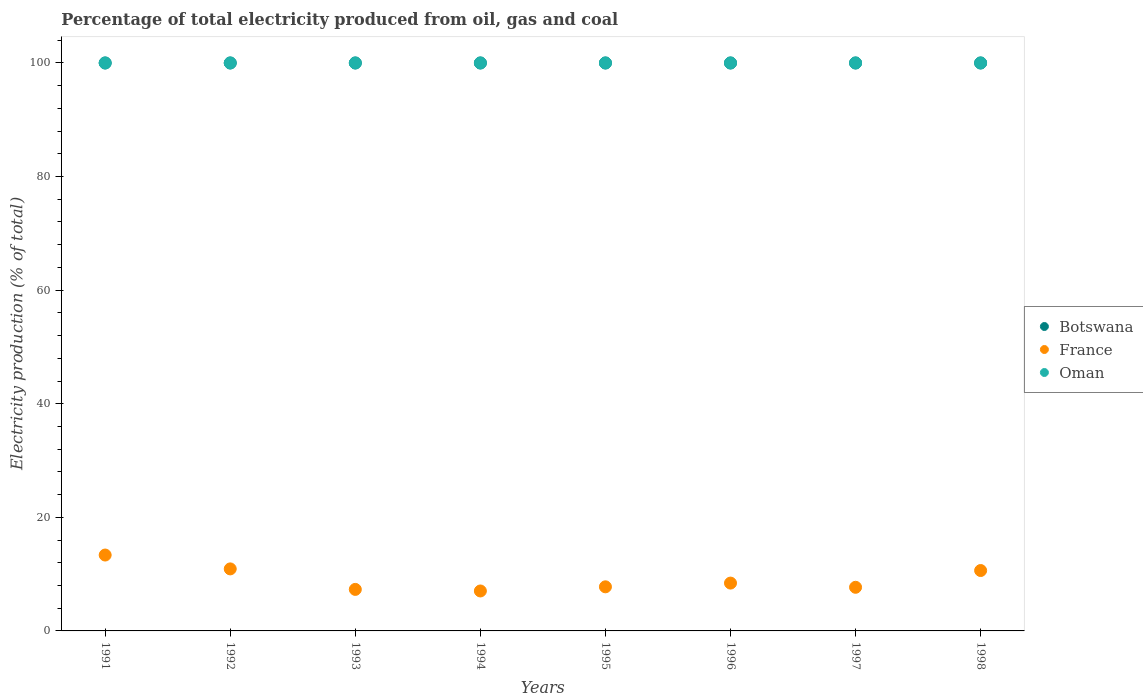How many different coloured dotlines are there?
Make the answer very short. 3. Is the number of dotlines equal to the number of legend labels?
Provide a short and direct response. Yes. In which year was the electricity production in in Botswana minimum?
Your answer should be very brief. 1991. What is the total electricity production in in Oman in the graph?
Your answer should be compact. 800. What is the difference between the electricity production in in France in 1995 and that in 1998?
Your response must be concise. -2.87. What is the average electricity production in in Botswana per year?
Provide a succinct answer. 100. In the year 1997, what is the difference between the electricity production in in France and electricity production in in Oman?
Offer a terse response. -92.32. What is the ratio of the electricity production in in Oman in 1994 to that in 1998?
Make the answer very short. 1. Is the difference between the electricity production in in France in 1991 and 1993 greater than the difference between the electricity production in in Oman in 1991 and 1993?
Provide a succinct answer. Yes. What is the difference between the highest and the second highest electricity production in in France?
Provide a short and direct response. 2.44. What is the difference between the highest and the lowest electricity production in in Botswana?
Your response must be concise. 0. In how many years, is the electricity production in in Botswana greater than the average electricity production in in Botswana taken over all years?
Offer a terse response. 0. Is the sum of the electricity production in in Botswana in 1991 and 1993 greater than the maximum electricity production in in France across all years?
Your answer should be compact. Yes. Is it the case that in every year, the sum of the electricity production in in France and electricity production in in Botswana  is greater than the electricity production in in Oman?
Offer a very short reply. Yes. Does the electricity production in in Botswana monotonically increase over the years?
Provide a succinct answer. No. How many dotlines are there?
Provide a succinct answer. 3. What is the difference between two consecutive major ticks on the Y-axis?
Your answer should be compact. 20. Does the graph contain grids?
Your answer should be compact. No. How many legend labels are there?
Your answer should be compact. 3. How are the legend labels stacked?
Give a very brief answer. Vertical. What is the title of the graph?
Make the answer very short. Percentage of total electricity produced from oil, gas and coal. Does "United Kingdom" appear as one of the legend labels in the graph?
Keep it short and to the point. No. What is the label or title of the X-axis?
Make the answer very short. Years. What is the label or title of the Y-axis?
Give a very brief answer. Electricity production (% of total). What is the Electricity production (% of total) of France in 1991?
Ensure brevity in your answer.  13.36. What is the Electricity production (% of total) in Oman in 1991?
Make the answer very short. 100. What is the Electricity production (% of total) of Botswana in 1992?
Your answer should be very brief. 100. What is the Electricity production (% of total) in France in 1992?
Offer a terse response. 10.92. What is the Electricity production (% of total) in Oman in 1992?
Offer a very short reply. 100. What is the Electricity production (% of total) of Botswana in 1993?
Ensure brevity in your answer.  100. What is the Electricity production (% of total) in France in 1993?
Offer a very short reply. 7.31. What is the Electricity production (% of total) in Oman in 1993?
Provide a short and direct response. 100. What is the Electricity production (% of total) in France in 1994?
Your response must be concise. 7.03. What is the Electricity production (% of total) of France in 1995?
Ensure brevity in your answer.  7.77. What is the Electricity production (% of total) in Oman in 1995?
Make the answer very short. 100. What is the Electricity production (% of total) in Botswana in 1996?
Give a very brief answer. 100. What is the Electricity production (% of total) in France in 1996?
Keep it short and to the point. 8.42. What is the Electricity production (% of total) of Botswana in 1997?
Your answer should be very brief. 100. What is the Electricity production (% of total) in France in 1997?
Ensure brevity in your answer.  7.68. What is the Electricity production (% of total) in Oman in 1997?
Offer a terse response. 100. What is the Electricity production (% of total) in France in 1998?
Make the answer very short. 10.63. Across all years, what is the maximum Electricity production (% of total) of Botswana?
Your response must be concise. 100. Across all years, what is the maximum Electricity production (% of total) of France?
Keep it short and to the point. 13.36. Across all years, what is the maximum Electricity production (% of total) in Oman?
Give a very brief answer. 100. Across all years, what is the minimum Electricity production (% of total) in France?
Make the answer very short. 7.03. Across all years, what is the minimum Electricity production (% of total) of Oman?
Offer a terse response. 100. What is the total Electricity production (% of total) of Botswana in the graph?
Provide a short and direct response. 800. What is the total Electricity production (% of total) in France in the graph?
Offer a terse response. 73.13. What is the total Electricity production (% of total) of Oman in the graph?
Offer a very short reply. 800. What is the difference between the Electricity production (% of total) of Botswana in 1991 and that in 1992?
Offer a terse response. 0. What is the difference between the Electricity production (% of total) of France in 1991 and that in 1992?
Make the answer very short. 2.44. What is the difference between the Electricity production (% of total) of Botswana in 1991 and that in 1993?
Make the answer very short. 0. What is the difference between the Electricity production (% of total) in France in 1991 and that in 1993?
Give a very brief answer. 6.05. What is the difference between the Electricity production (% of total) of Botswana in 1991 and that in 1994?
Your answer should be compact. 0. What is the difference between the Electricity production (% of total) in France in 1991 and that in 1994?
Give a very brief answer. 6.33. What is the difference between the Electricity production (% of total) in France in 1991 and that in 1995?
Provide a short and direct response. 5.6. What is the difference between the Electricity production (% of total) in Oman in 1991 and that in 1995?
Keep it short and to the point. 0. What is the difference between the Electricity production (% of total) of Botswana in 1991 and that in 1996?
Your answer should be very brief. 0. What is the difference between the Electricity production (% of total) in France in 1991 and that in 1996?
Provide a short and direct response. 4.94. What is the difference between the Electricity production (% of total) of Oman in 1991 and that in 1996?
Give a very brief answer. 0. What is the difference between the Electricity production (% of total) in France in 1991 and that in 1997?
Your response must be concise. 5.68. What is the difference between the Electricity production (% of total) of Botswana in 1991 and that in 1998?
Provide a short and direct response. 0. What is the difference between the Electricity production (% of total) of France in 1991 and that in 1998?
Offer a terse response. 2.73. What is the difference between the Electricity production (% of total) in Oman in 1991 and that in 1998?
Your answer should be very brief. 0. What is the difference between the Electricity production (% of total) of Botswana in 1992 and that in 1993?
Offer a terse response. 0. What is the difference between the Electricity production (% of total) in France in 1992 and that in 1993?
Your answer should be compact. 3.61. What is the difference between the Electricity production (% of total) in Oman in 1992 and that in 1993?
Ensure brevity in your answer.  0. What is the difference between the Electricity production (% of total) in Botswana in 1992 and that in 1994?
Make the answer very short. 0. What is the difference between the Electricity production (% of total) in France in 1992 and that in 1994?
Make the answer very short. 3.89. What is the difference between the Electricity production (% of total) of Botswana in 1992 and that in 1995?
Offer a terse response. 0. What is the difference between the Electricity production (% of total) of France in 1992 and that in 1995?
Make the answer very short. 3.15. What is the difference between the Electricity production (% of total) of Botswana in 1992 and that in 1996?
Your response must be concise. 0. What is the difference between the Electricity production (% of total) in France in 1992 and that in 1996?
Provide a succinct answer. 2.5. What is the difference between the Electricity production (% of total) in Botswana in 1992 and that in 1997?
Your answer should be very brief. 0. What is the difference between the Electricity production (% of total) in France in 1992 and that in 1997?
Provide a short and direct response. 3.24. What is the difference between the Electricity production (% of total) of Oman in 1992 and that in 1997?
Give a very brief answer. 0. What is the difference between the Electricity production (% of total) of France in 1992 and that in 1998?
Your answer should be very brief. 0.29. What is the difference between the Electricity production (% of total) in Oman in 1992 and that in 1998?
Your response must be concise. 0. What is the difference between the Electricity production (% of total) of France in 1993 and that in 1994?
Provide a succinct answer. 0.28. What is the difference between the Electricity production (% of total) of Oman in 1993 and that in 1994?
Offer a terse response. 0. What is the difference between the Electricity production (% of total) of France in 1993 and that in 1995?
Offer a terse response. -0.45. What is the difference between the Electricity production (% of total) of Oman in 1993 and that in 1995?
Your answer should be compact. 0. What is the difference between the Electricity production (% of total) of France in 1993 and that in 1996?
Offer a terse response. -1.11. What is the difference between the Electricity production (% of total) of Oman in 1993 and that in 1996?
Offer a very short reply. 0. What is the difference between the Electricity production (% of total) of France in 1993 and that in 1997?
Provide a succinct answer. -0.37. What is the difference between the Electricity production (% of total) of Oman in 1993 and that in 1997?
Give a very brief answer. 0. What is the difference between the Electricity production (% of total) in France in 1993 and that in 1998?
Offer a very short reply. -3.32. What is the difference between the Electricity production (% of total) in France in 1994 and that in 1995?
Your answer should be very brief. -0.73. What is the difference between the Electricity production (% of total) in Botswana in 1994 and that in 1996?
Ensure brevity in your answer.  0. What is the difference between the Electricity production (% of total) in France in 1994 and that in 1996?
Your response must be concise. -1.39. What is the difference between the Electricity production (% of total) of France in 1994 and that in 1997?
Ensure brevity in your answer.  -0.65. What is the difference between the Electricity production (% of total) in France in 1994 and that in 1998?
Provide a succinct answer. -3.6. What is the difference between the Electricity production (% of total) of Oman in 1994 and that in 1998?
Provide a short and direct response. 0. What is the difference between the Electricity production (% of total) of Botswana in 1995 and that in 1996?
Ensure brevity in your answer.  0. What is the difference between the Electricity production (% of total) of France in 1995 and that in 1996?
Your response must be concise. -0.66. What is the difference between the Electricity production (% of total) of Oman in 1995 and that in 1996?
Your response must be concise. 0. What is the difference between the Electricity production (% of total) of Botswana in 1995 and that in 1997?
Your answer should be very brief. 0. What is the difference between the Electricity production (% of total) in France in 1995 and that in 1997?
Offer a terse response. 0.08. What is the difference between the Electricity production (% of total) of Oman in 1995 and that in 1997?
Your answer should be very brief. 0. What is the difference between the Electricity production (% of total) in France in 1995 and that in 1998?
Your answer should be very brief. -2.87. What is the difference between the Electricity production (% of total) in Botswana in 1996 and that in 1997?
Make the answer very short. 0. What is the difference between the Electricity production (% of total) of France in 1996 and that in 1997?
Your response must be concise. 0.74. What is the difference between the Electricity production (% of total) of Botswana in 1996 and that in 1998?
Make the answer very short. 0. What is the difference between the Electricity production (% of total) in France in 1996 and that in 1998?
Provide a short and direct response. -2.21. What is the difference between the Electricity production (% of total) in Oman in 1996 and that in 1998?
Give a very brief answer. 0. What is the difference between the Electricity production (% of total) of Botswana in 1997 and that in 1998?
Your answer should be very brief. 0. What is the difference between the Electricity production (% of total) in France in 1997 and that in 1998?
Your answer should be compact. -2.95. What is the difference between the Electricity production (% of total) in Botswana in 1991 and the Electricity production (% of total) in France in 1992?
Offer a very short reply. 89.08. What is the difference between the Electricity production (% of total) in France in 1991 and the Electricity production (% of total) in Oman in 1992?
Ensure brevity in your answer.  -86.64. What is the difference between the Electricity production (% of total) of Botswana in 1991 and the Electricity production (% of total) of France in 1993?
Your answer should be compact. 92.69. What is the difference between the Electricity production (% of total) of France in 1991 and the Electricity production (% of total) of Oman in 1993?
Offer a terse response. -86.64. What is the difference between the Electricity production (% of total) in Botswana in 1991 and the Electricity production (% of total) in France in 1994?
Your response must be concise. 92.97. What is the difference between the Electricity production (% of total) of Botswana in 1991 and the Electricity production (% of total) of Oman in 1994?
Provide a short and direct response. 0. What is the difference between the Electricity production (% of total) in France in 1991 and the Electricity production (% of total) in Oman in 1994?
Offer a terse response. -86.64. What is the difference between the Electricity production (% of total) of Botswana in 1991 and the Electricity production (% of total) of France in 1995?
Keep it short and to the point. 92.23. What is the difference between the Electricity production (% of total) of France in 1991 and the Electricity production (% of total) of Oman in 1995?
Your response must be concise. -86.64. What is the difference between the Electricity production (% of total) of Botswana in 1991 and the Electricity production (% of total) of France in 1996?
Offer a terse response. 91.58. What is the difference between the Electricity production (% of total) in France in 1991 and the Electricity production (% of total) in Oman in 1996?
Ensure brevity in your answer.  -86.64. What is the difference between the Electricity production (% of total) in Botswana in 1991 and the Electricity production (% of total) in France in 1997?
Provide a succinct answer. 92.32. What is the difference between the Electricity production (% of total) of France in 1991 and the Electricity production (% of total) of Oman in 1997?
Ensure brevity in your answer.  -86.64. What is the difference between the Electricity production (% of total) of Botswana in 1991 and the Electricity production (% of total) of France in 1998?
Your response must be concise. 89.37. What is the difference between the Electricity production (% of total) in Botswana in 1991 and the Electricity production (% of total) in Oman in 1998?
Your response must be concise. 0. What is the difference between the Electricity production (% of total) of France in 1991 and the Electricity production (% of total) of Oman in 1998?
Offer a terse response. -86.64. What is the difference between the Electricity production (% of total) of Botswana in 1992 and the Electricity production (% of total) of France in 1993?
Make the answer very short. 92.69. What is the difference between the Electricity production (% of total) in Botswana in 1992 and the Electricity production (% of total) in Oman in 1993?
Your answer should be very brief. 0. What is the difference between the Electricity production (% of total) of France in 1992 and the Electricity production (% of total) of Oman in 1993?
Make the answer very short. -89.08. What is the difference between the Electricity production (% of total) of Botswana in 1992 and the Electricity production (% of total) of France in 1994?
Your answer should be compact. 92.97. What is the difference between the Electricity production (% of total) of Botswana in 1992 and the Electricity production (% of total) of Oman in 1994?
Offer a terse response. 0. What is the difference between the Electricity production (% of total) of France in 1992 and the Electricity production (% of total) of Oman in 1994?
Your answer should be compact. -89.08. What is the difference between the Electricity production (% of total) in Botswana in 1992 and the Electricity production (% of total) in France in 1995?
Give a very brief answer. 92.23. What is the difference between the Electricity production (% of total) of Botswana in 1992 and the Electricity production (% of total) of Oman in 1995?
Keep it short and to the point. 0. What is the difference between the Electricity production (% of total) in France in 1992 and the Electricity production (% of total) in Oman in 1995?
Make the answer very short. -89.08. What is the difference between the Electricity production (% of total) of Botswana in 1992 and the Electricity production (% of total) of France in 1996?
Ensure brevity in your answer.  91.58. What is the difference between the Electricity production (% of total) of France in 1992 and the Electricity production (% of total) of Oman in 1996?
Your answer should be compact. -89.08. What is the difference between the Electricity production (% of total) of Botswana in 1992 and the Electricity production (% of total) of France in 1997?
Keep it short and to the point. 92.32. What is the difference between the Electricity production (% of total) of France in 1992 and the Electricity production (% of total) of Oman in 1997?
Give a very brief answer. -89.08. What is the difference between the Electricity production (% of total) of Botswana in 1992 and the Electricity production (% of total) of France in 1998?
Your answer should be very brief. 89.37. What is the difference between the Electricity production (% of total) in France in 1992 and the Electricity production (% of total) in Oman in 1998?
Offer a terse response. -89.08. What is the difference between the Electricity production (% of total) in Botswana in 1993 and the Electricity production (% of total) in France in 1994?
Give a very brief answer. 92.97. What is the difference between the Electricity production (% of total) in Botswana in 1993 and the Electricity production (% of total) in Oman in 1994?
Offer a very short reply. 0. What is the difference between the Electricity production (% of total) in France in 1993 and the Electricity production (% of total) in Oman in 1994?
Provide a short and direct response. -92.69. What is the difference between the Electricity production (% of total) of Botswana in 1993 and the Electricity production (% of total) of France in 1995?
Give a very brief answer. 92.23. What is the difference between the Electricity production (% of total) in Botswana in 1993 and the Electricity production (% of total) in Oman in 1995?
Your answer should be compact. 0. What is the difference between the Electricity production (% of total) in France in 1993 and the Electricity production (% of total) in Oman in 1995?
Make the answer very short. -92.69. What is the difference between the Electricity production (% of total) in Botswana in 1993 and the Electricity production (% of total) in France in 1996?
Ensure brevity in your answer.  91.58. What is the difference between the Electricity production (% of total) of France in 1993 and the Electricity production (% of total) of Oman in 1996?
Provide a succinct answer. -92.69. What is the difference between the Electricity production (% of total) in Botswana in 1993 and the Electricity production (% of total) in France in 1997?
Offer a very short reply. 92.32. What is the difference between the Electricity production (% of total) in Botswana in 1993 and the Electricity production (% of total) in Oman in 1997?
Offer a very short reply. 0. What is the difference between the Electricity production (% of total) in France in 1993 and the Electricity production (% of total) in Oman in 1997?
Keep it short and to the point. -92.69. What is the difference between the Electricity production (% of total) in Botswana in 1993 and the Electricity production (% of total) in France in 1998?
Your answer should be very brief. 89.37. What is the difference between the Electricity production (% of total) in Botswana in 1993 and the Electricity production (% of total) in Oman in 1998?
Make the answer very short. 0. What is the difference between the Electricity production (% of total) of France in 1993 and the Electricity production (% of total) of Oman in 1998?
Your answer should be very brief. -92.69. What is the difference between the Electricity production (% of total) in Botswana in 1994 and the Electricity production (% of total) in France in 1995?
Your response must be concise. 92.23. What is the difference between the Electricity production (% of total) in France in 1994 and the Electricity production (% of total) in Oman in 1995?
Give a very brief answer. -92.97. What is the difference between the Electricity production (% of total) of Botswana in 1994 and the Electricity production (% of total) of France in 1996?
Your response must be concise. 91.58. What is the difference between the Electricity production (% of total) in France in 1994 and the Electricity production (% of total) in Oman in 1996?
Your answer should be compact. -92.97. What is the difference between the Electricity production (% of total) in Botswana in 1994 and the Electricity production (% of total) in France in 1997?
Offer a terse response. 92.32. What is the difference between the Electricity production (% of total) of France in 1994 and the Electricity production (% of total) of Oman in 1997?
Your answer should be very brief. -92.97. What is the difference between the Electricity production (% of total) of Botswana in 1994 and the Electricity production (% of total) of France in 1998?
Your answer should be very brief. 89.37. What is the difference between the Electricity production (% of total) of France in 1994 and the Electricity production (% of total) of Oman in 1998?
Ensure brevity in your answer.  -92.97. What is the difference between the Electricity production (% of total) of Botswana in 1995 and the Electricity production (% of total) of France in 1996?
Make the answer very short. 91.58. What is the difference between the Electricity production (% of total) in France in 1995 and the Electricity production (% of total) in Oman in 1996?
Your response must be concise. -92.23. What is the difference between the Electricity production (% of total) of Botswana in 1995 and the Electricity production (% of total) of France in 1997?
Provide a succinct answer. 92.32. What is the difference between the Electricity production (% of total) of Botswana in 1995 and the Electricity production (% of total) of Oman in 1997?
Make the answer very short. 0. What is the difference between the Electricity production (% of total) of France in 1995 and the Electricity production (% of total) of Oman in 1997?
Offer a terse response. -92.23. What is the difference between the Electricity production (% of total) of Botswana in 1995 and the Electricity production (% of total) of France in 1998?
Offer a very short reply. 89.37. What is the difference between the Electricity production (% of total) in Botswana in 1995 and the Electricity production (% of total) in Oman in 1998?
Provide a short and direct response. 0. What is the difference between the Electricity production (% of total) of France in 1995 and the Electricity production (% of total) of Oman in 1998?
Offer a very short reply. -92.23. What is the difference between the Electricity production (% of total) in Botswana in 1996 and the Electricity production (% of total) in France in 1997?
Offer a terse response. 92.32. What is the difference between the Electricity production (% of total) in Botswana in 1996 and the Electricity production (% of total) in Oman in 1997?
Make the answer very short. 0. What is the difference between the Electricity production (% of total) of France in 1996 and the Electricity production (% of total) of Oman in 1997?
Your response must be concise. -91.58. What is the difference between the Electricity production (% of total) of Botswana in 1996 and the Electricity production (% of total) of France in 1998?
Your answer should be compact. 89.37. What is the difference between the Electricity production (% of total) of Botswana in 1996 and the Electricity production (% of total) of Oman in 1998?
Your answer should be compact. 0. What is the difference between the Electricity production (% of total) in France in 1996 and the Electricity production (% of total) in Oman in 1998?
Your answer should be compact. -91.58. What is the difference between the Electricity production (% of total) in Botswana in 1997 and the Electricity production (% of total) in France in 1998?
Offer a very short reply. 89.37. What is the difference between the Electricity production (% of total) in France in 1997 and the Electricity production (% of total) in Oman in 1998?
Provide a succinct answer. -92.32. What is the average Electricity production (% of total) in France per year?
Your response must be concise. 9.14. In the year 1991, what is the difference between the Electricity production (% of total) of Botswana and Electricity production (% of total) of France?
Your response must be concise. 86.64. In the year 1991, what is the difference between the Electricity production (% of total) in Botswana and Electricity production (% of total) in Oman?
Your response must be concise. 0. In the year 1991, what is the difference between the Electricity production (% of total) in France and Electricity production (% of total) in Oman?
Your response must be concise. -86.64. In the year 1992, what is the difference between the Electricity production (% of total) of Botswana and Electricity production (% of total) of France?
Offer a very short reply. 89.08. In the year 1992, what is the difference between the Electricity production (% of total) of Botswana and Electricity production (% of total) of Oman?
Offer a very short reply. 0. In the year 1992, what is the difference between the Electricity production (% of total) in France and Electricity production (% of total) in Oman?
Keep it short and to the point. -89.08. In the year 1993, what is the difference between the Electricity production (% of total) of Botswana and Electricity production (% of total) of France?
Make the answer very short. 92.69. In the year 1993, what is the difference between the Electricity production (% of total) of Botswana and Electricity production (% of total) of Oman?
Give a very brief answer. 0. In the year 1993, what is the difference between the Electricity production (% of total) of France and Electricity production (% of total) of Oman?
Make the answer very short. -92.69. In the year 1994, what is the difference between the Electricity production (% of total) in Botswana and Electricity production (% of total) in France?
Ensure brevity in your answer.  92.97. In the year 1994, what is the difference between the Electricity production (% of total) in Botswana and Electricity production (% of total) in Oman?
Make the answer very short. 0. In the year 1994, what is the difference between the Electricity production (% of total) in France and Electricity production (% of total) in Oman?
Make the answer very short. -92.97. In the year 1995, what is the difference between the Electricity production (% of total) in Botswana and Electricity production (% of total) in France?
Offer a very short reply. 92.23. In the year 1995, what is the difference between the Electricity production (% of total) in France and Electricity production (% of total) in Oman?
Make the answer very short. -92.23. In the year 1996, what is the difference between the Electricity production (% of total) of Botswana and Electricity production (% of total) of France?
Offer a terse response. 91.58. In the year 1996, what is the difference between the Electricity production (% of total) of Botswana and Electricity production (% of total) of Oman?
Your answer should be very brief. 0. In the year 1996, what is the difference between the Electricity production (% of total) in France and Electricity production (% of total) in Oman?
Keep it short and to the point. -91.58. In the year 1997, what is the difference between the Electricity production (% of total) in Botswana and Electricity production (% of total) in France?
Provide a succinct answer. 92.32. In the year 1997, what is the difference between the Electricity production (% of total) in Botswana and Electricity production (% of total) in Oman?
Provide a succinct answer. 0. In the year 1997, what is the difference between the Electricity production (% of total) of France and Electricity production (% of total) of Oman?
Offer a very short reply. -92.32. In the year 1998, what is the difference between the Electricity production (% of total) of Botswana and Electricity production (% of total) of France?
Make the answer very short. 89.37. In the year 1998, what is the difference between the Electricity production (% of total) in France and Electricity production (% of total) in Oman?
Offer a terse response. -89.37. What is the ratio of the Electricity production (% of total) of Botswana in 1991 to that in 1992?
Provide a succinct answer. 1. What is the ratio of the Electricity production (% of total) in France in 1991 to that in 1992?
Your answer should be compact. 1.22. What is the ratio of the Electricity production (% of total) in Oman in 1991 to that in 1992?
Ensure brevity in your answer.  1. What is the ratio of the Electricity production (% of total) of Botswana in 1991 to that in 1993?
Offer a very short reply. 1. What is the ratio of the Electricity production (% of total) of France in 1991 to that in 1993?
Provide a short and direct response. 1.83. What is the ratio of the Electricity production (% of total) of Oman in 1991 to that in 1993?
Keep it short and to the point. 1. What is the ratio of the Electricity production (% of total) of France in 1991 to that in 1994?
Offer a very short reply. 1.9. What is the ratio of the Electricity production (% of total) in Botswana in 1991 to that in 1995?
Offer a very short reply. 1. What is the ratio of the Electricity production (% of total) in France in 1991 to that in 1995?
Provide a succinct answer. 1.72. What is the ratio of the Electricity production (% of total) in Oman in 1991 to that in 1995?
Keep it short and to the point. 1. What is the ratio of the Electricity production (% of total) of France in 1991 to that in 1996?
Your answer should be very brief. 1.59. What is the ratio of the Electricity production (% of total) in Oman in 1991 to that in 1996?
Provide a short and direct response. 1. What is the ratio of the Electricity production (% of total) in France in 1991 to that in 1997?
Your response must be concise. 1.74. What is the ratio of the Electricity production (% of total) in Botswana in 1991 to that in 1998?
Give a very brief answer. 1. What is the ratio of the Electricity production (% of total) of France in 1991 to that in 1998?
Provide a succinct answer. 1.26. What is the ratio of the Electricity production (% of total) in Oman in 1991 to that in 1998?
Keep it short and to the point. 1. What is the ratio of the Electricity production (% of total) of Botswana in 1992 to that in 1993?
Offer a very short reply. 1. What is the ratio of the Electricity production (% of total) in France in 1992 to that in 1993?
Provide a short and direct response. 1.49. What is the ratio of the Electricity production (% of total) of France in 1992 to that in 1994?
Your response must be concise. 1.55. What is the ratio of the Electricity production (% of total) of France in 1992 to that in 1995?
Offer a very short reply. 1.41. What is the ratio of the Electricity production (% of total) of Oman in 1992 to that in 1995?
Ensure brevity in your answer.  1. What is the ratio of the Electricity production (% of total) in Botswana in 1992 to that in 1996?
Offer a terse response. 1. What is the ratio of the Electricity production (% of total) of France in 1992 to that in 1996?
Keep it short and to the point. 1.3. What is the ratio of the Electricity production (% of total) in France in 1992 to that in 1997?
Offer a very short reply. 1.42. What is the ratio of the Electricity production (% of total) in Oman in 1992 to that in 1997?
Provide a short and direct response. 1. What is the ratio of the Electricity production (% of total) of Botswana in 1992 to that in 1998?
Offer a terse response. 1. What is the ratio of the Electricity production (% of total) of France in 1992 to that in 1998?
Provide a short and direct response. 1.03. What is the ratio of the Electricity production (% of total) in Oman in 1992 to that in 1998?
Give a very brief answer. 1. What is the ratio of the Electricity production (% of total) in Botswana in 1993 to that in 1994?
Make the answer very short. 1. What is the ratio of the Electricity production (% of total) in France in 1993 to that in 1994?
Make the answer very short. 1.04. What is the ratio of the Electricity production (% of total) of France in 1993 to that in 1995?
Your answer should be very brief. 0.94. What is the ratio of the Electricity production (% of total) of France in 1993 to that in 1996?
Ensure brevity in your answer.  0.87. What is the ratio of the Electricity production (% of total) of Oman in 1993 to that in 1996?
Keep it short and to the point. 1. What is the ratio of the Electricity production (% of total) in Botswana in 1993 to that in 1997?
Offer a terse response. 1. What is the ratio of the Electricity production (% of total) in France in 1993 to that in 1997?
Ensure brevity in your answer.  0.95. What is the ratio of the Electricity production (% of total) of Oman in 1993 to that in 1997?
Your answer should be very brief. 1. What is the ratio of the Electricity production (% of total) of Botswana in 1993 to that in 1998?
Make the answer very short. 1. What is the ratio of the Electricity production (% of total) of France in 1993 to that in 1998?
Offer a very short reply. 0.69. What is the ratio of the Electricity production (% of total) of Botswana in 1994 to that in 1995?
Your response must be concise. 1. What is the ratio of the Electricity production (% of total) in France in 1994 to that in 1995?
Give a very brief answer. 0.91. What is the ratio of the Electricity production (% of total) of France in 1994 to that in 1996?
Your answer should be very brief. 0.84. What is the ratio of the Electricity production (% of total) in Oman in 1994 to that in 1996?
Provide a succinct answer. 1. What is the ratio of the Electricity production (% of total) of France in 1994 to that in 1997?
Provide a succinct answer. 0.92. What is the ratio of the Electricity production (% of total) in Oman in 1994 to that in 1997?
Your answer should be compact. 1. What is the ratio of the Electricity production (% of total) in Botswana in 1994 to that in 1998?
Your response must be concise. 1. What is the ratio of the Electricity production (% of total) in France in 1994 to that in 1998?
Offer a very short reply. 0.66. What is the ratio of the Electricity production (% of total) of Oman in 1994 to that in 1998?
Give a very brief answer. 1. What is the ratio of the Electricity production (% of total) of France in 1995 to that in 1996?
Your answer should be very brief. 0.92. What is the ratio of the Electricity production (% of total) of Botswana in 1995 to that in 1997?
Provide a succinct answer. 1. What is the ratio of the Electricity production (% of total) in France in 1995 to that in 1997?
Your answer should be compact. 1.01. What is the ratio of the Electricity production (% of total) in Oman in 1995 to that in 1997?
Ensure brevity in your answer.  1. What is the ratio of the Electricity production (% of total) of Botswana in 1995 to that in 1998?
Your answer should be very brief. 1. What is the ratio of the Electricity production (% of total) in France in 1995 to that in 1998?
Provide a succinct answer. 0.73. What is the ratio of the Electricity production (% of total) in France in 1996 to that in 1997?
Your response must be concise. 1.1. What is the ratio of the Electricity production (% of total) of Oman in 1996 to that in 1997?
Make the answer very short. 1. What is the ratio of the Electricity production (% of total) in France in 1996 to that in 1998?
Give a very brief answer. 0.79. What is the ratio of the Electricity production (% of total) of France in 1997 to that in 1998?
Your answer should be compact. 0.72. What is the ratio of the Electricity production (% of total) of Oman in 1997 to that in 1998?
Your response must be concise. 1. What is the difference between the highest and the second highest Electricity production (% of total) in Botswana?
Offer a terse response. 0. What is the difference between the highest and the second highest Electricity production (% of total) of France?
Keep it short and to the point. 2.44. What is the difference between the highest and the lowest Electricity production (% of total) of France?
Offer a very short reply. 6.33. What is the difference between the highest and the lowest Electricity production (% of total) of Oman?
Offer a terse response. 0. 